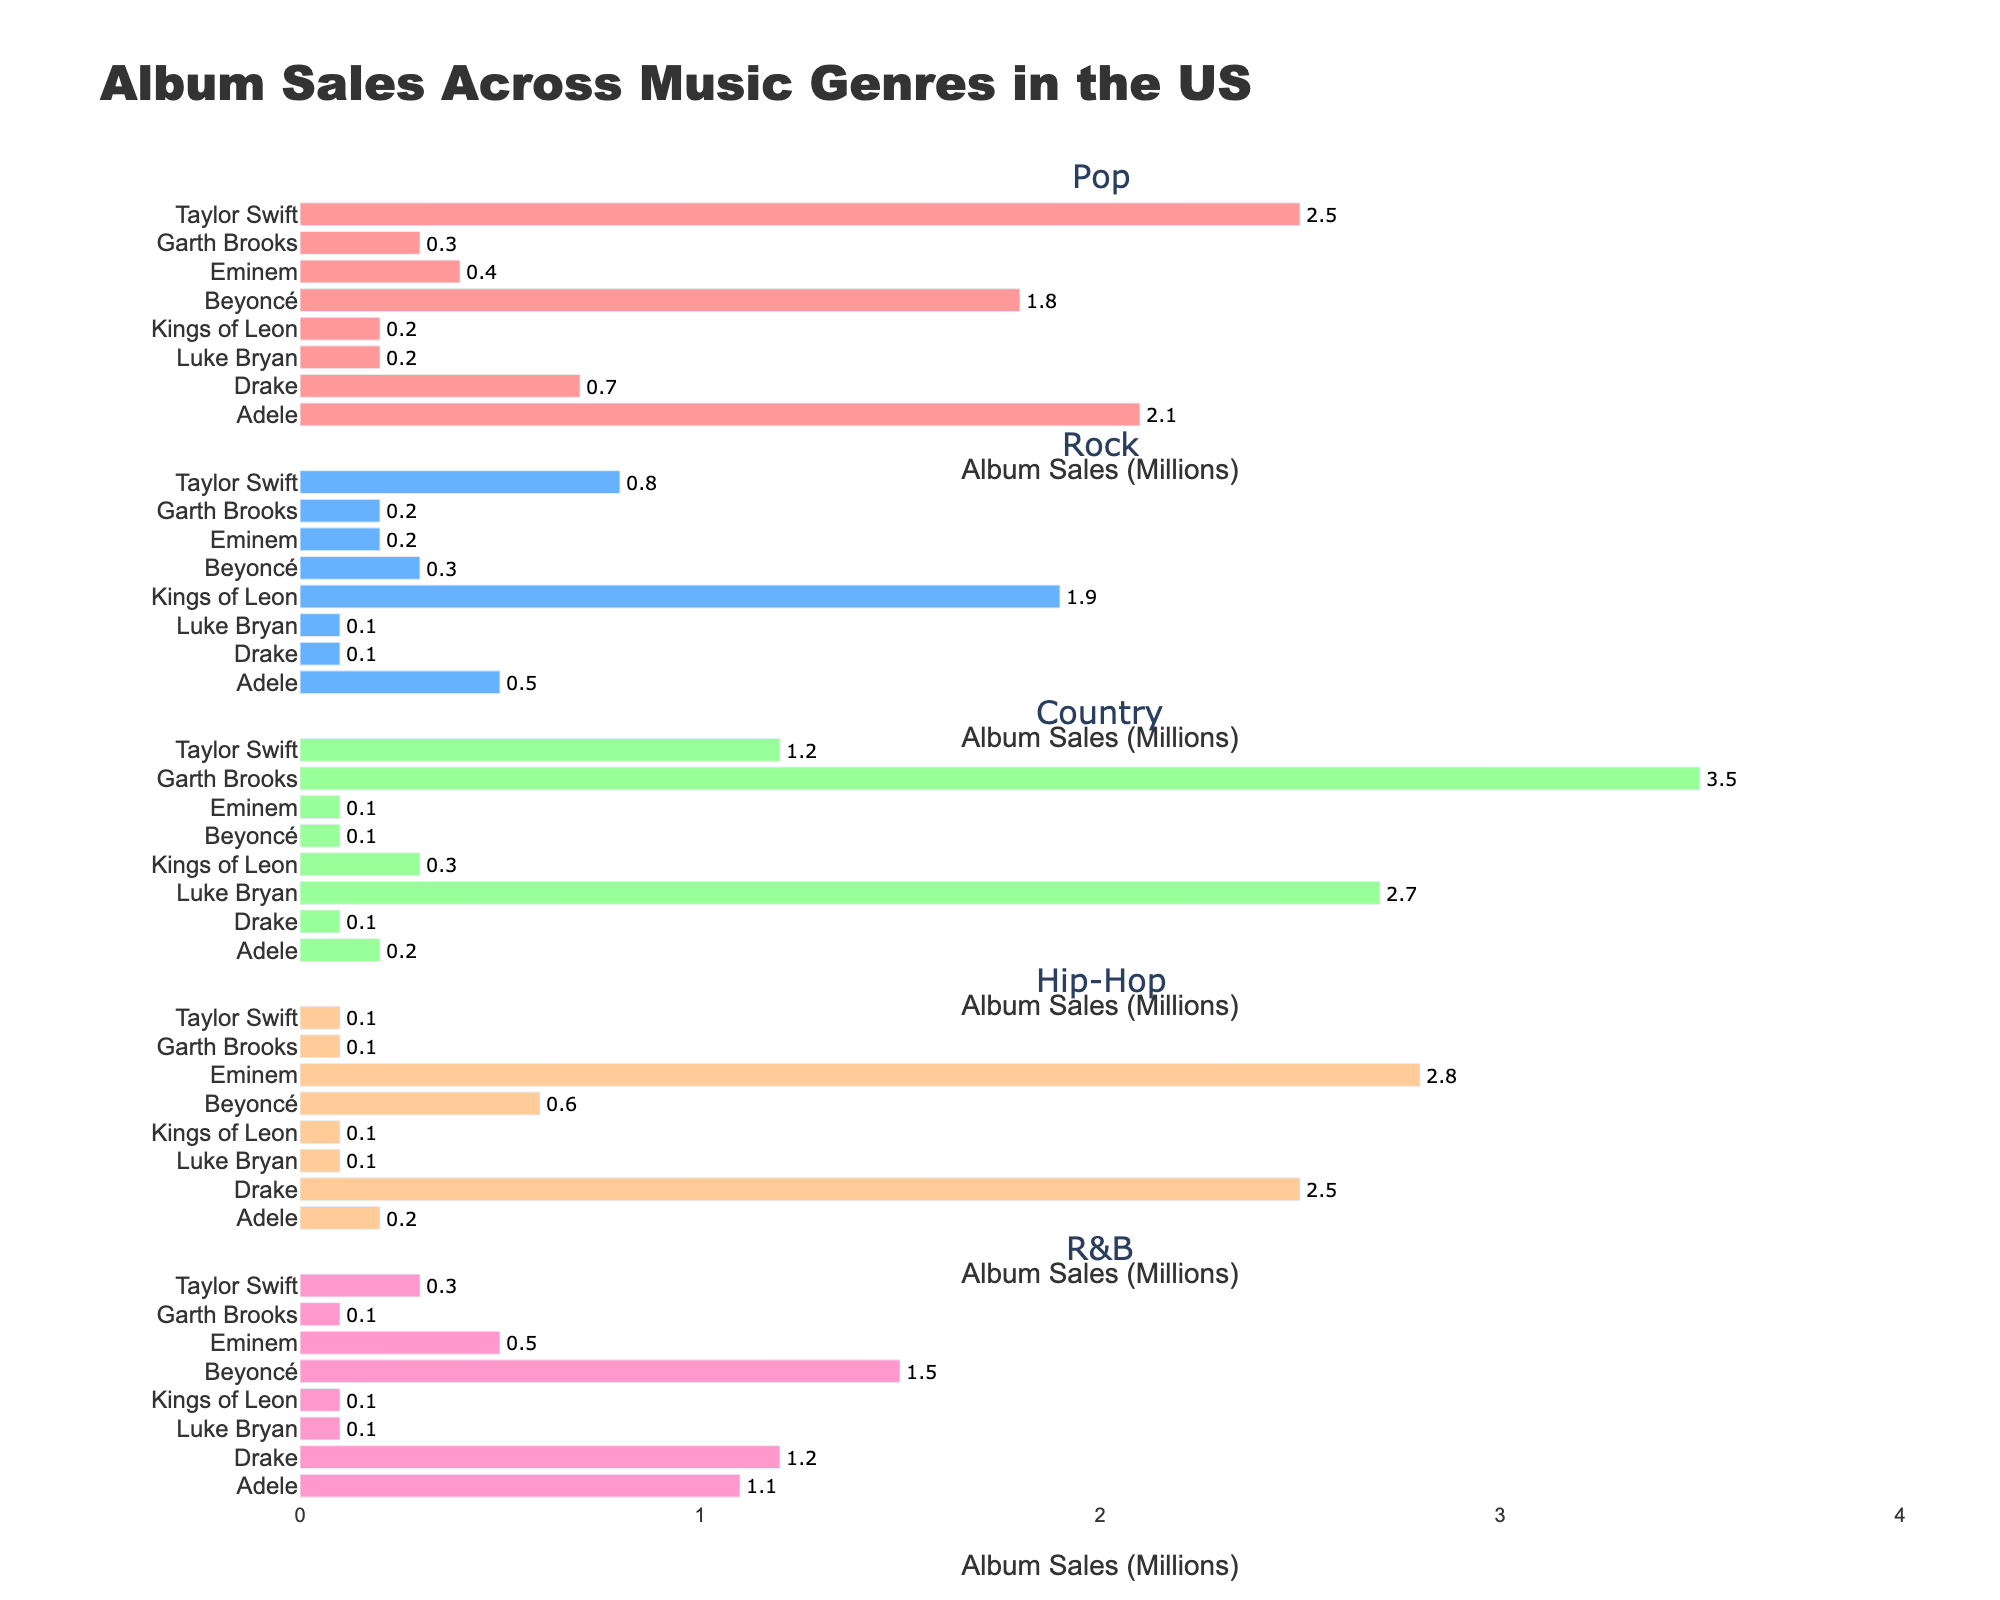what is the title of the figure? The title of the figure is displayed at the top, and it can be easily read without any additional steps.
Answer: Age Distribution of Ski Lesson Participants How many subplots does the figure have? The figure includes one subplot for each age group. We can count these subplots easily by looking at the small titles or separate sections they form.
Answer: 5 Which month has the highest number of participants aged 18-30? We need to look at the "18-30" subplot and find the tallest peak, which corresponds to the month with the highest number. We see that March has the highest peak for this age group.
Answer: March What is the trend for participants under 18 from December to April? By looking at the "Under 18" subplot, we observe whether the line goes up, down, or stays the same over the months. The line decreases from December to April.
Answer: Decreasing What are the participant numbers for "46-60" age group in February and March, and what's the difference? From the "46-60" subplot, identify the points for February and March. February has 20 participants, and March has 22 participants. The difference is calculated as 22 - 20.
Answer: 2 What month has the lowest number of participants aged under 18, and how many participants were there? In the "Under 18" subplot, find the lowest point on the graph and identify its corresponding month and the value. April has the lowest number, which is 25.
Answer: April, 25 How does the number of participants aged 31-45 change from December to April? Observing the "31-45" subplot, we look at the line's overall shape from December to April to understand whether it increases or decreases overall. The number of participants gradually increases from December to April.
Answer: Increases Compare the number of participants over 60 between January and February. Which month has more participants and by how much? From the "Over 60" subplot, check the values for January and February. January has 12 participants, and February has 15. February has more participants; thus the difference is 15 - 12.
Answer: February, by 3 Which age group shows the most significant increase in participants from December to April? By looking at each age group's subplot and comparing the distance between the points in December and April, we see that the "46-60" age group shows the most considerable increase from 15 to 24.
Answer: 46-60 